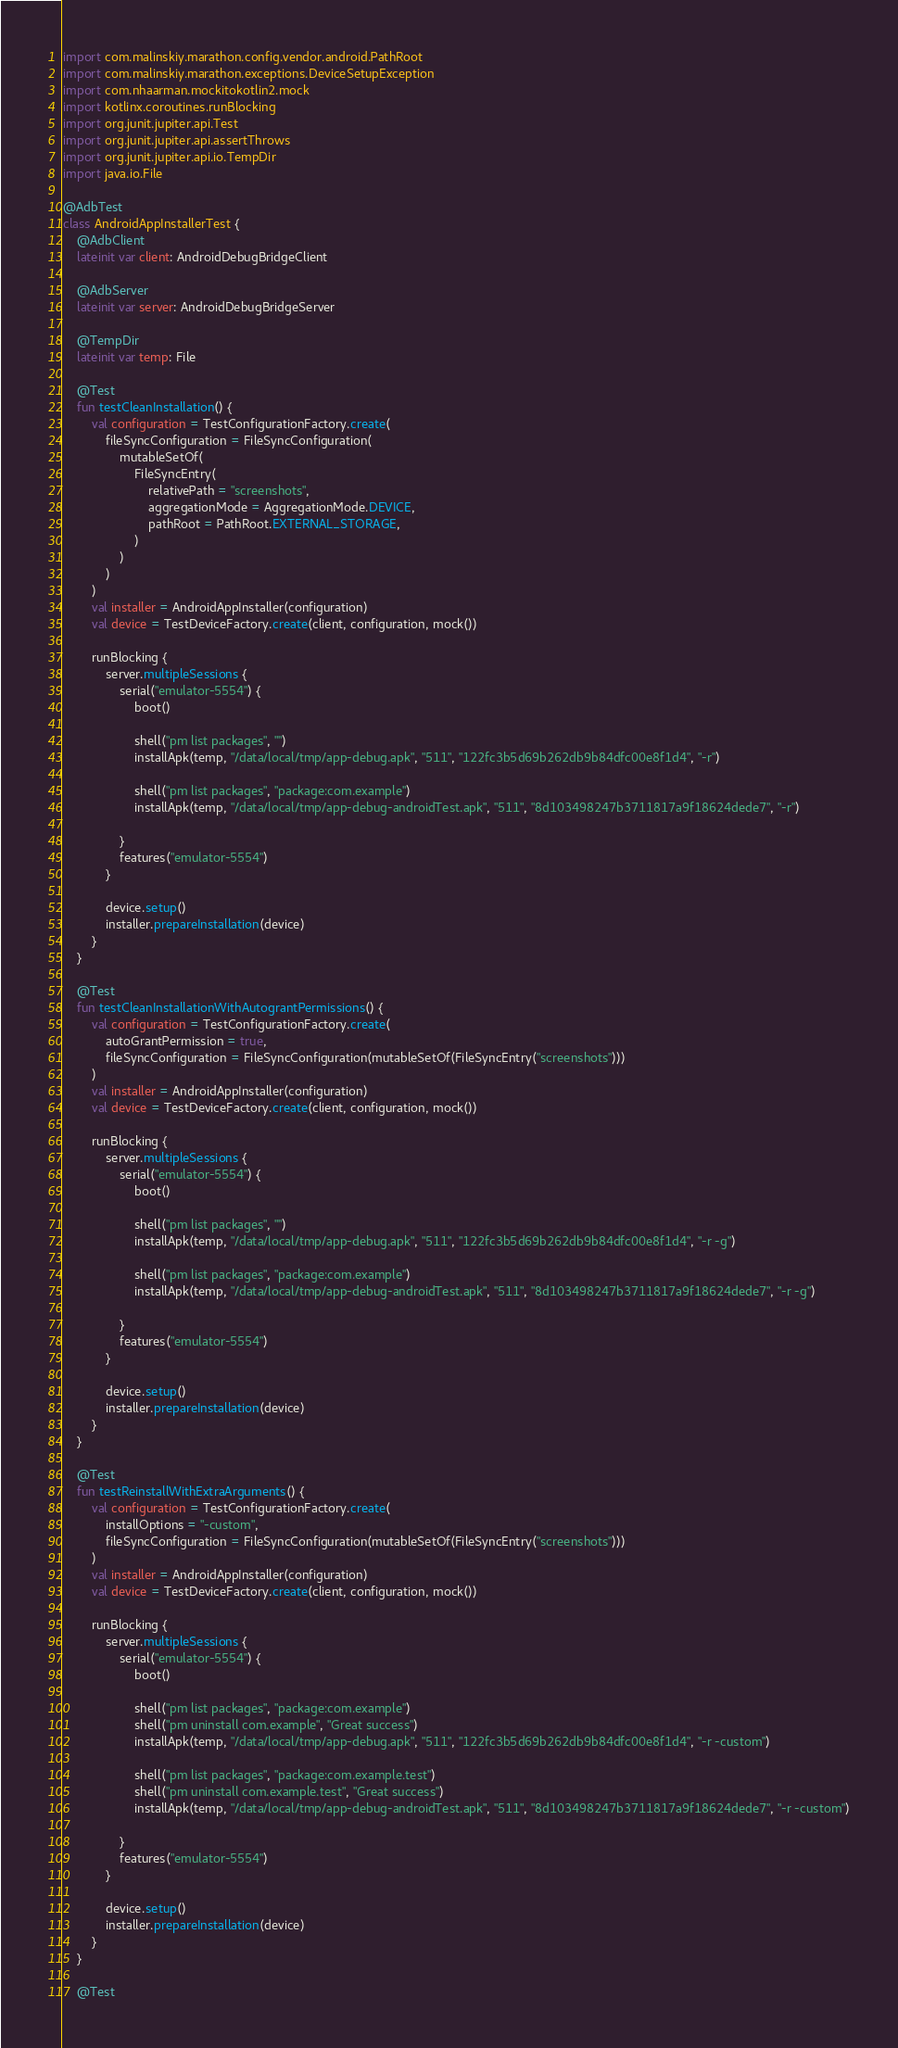<code> <loc_0><loc_0><loc_500><loc_500><_Kotlin_>import com.malinskiy.marathon.config.vendor.android.PathRoot
import com.malinskiy.marathon.exceptions.DeviceSetupException
import com.nhaarman.mockitokotlin2.mock
import kotlinx.coroutines.runBlocking
import org.junit.jupiter.api.Test
import org.junit.jupiter.api.assertThrows
import org.junit.jupiter.api.io.TempDir
import java.io.File

@AdbTest
class AndroidAppInstallerTest {
    @AdbClient
    lateinit var client: AndroidDebugBridgeClient

    @AdbServer
    lateinit var server: AndroidDebugBridgeServer

    @TempDir
    lateinit var temp: File

    @Test
    fun testCleanInstallation() {
        val configuration = TestConfigurationFactory.create(
            fileSyncConfiguration = FileSyncConfiguration(
                mutableSetOf(
                    FileSyncEntry(
                        relativePath = "screenshots",
                        aggregationMode = AggregationMode.DEVICE,
                        pathRoot = PathRoot.EXTERNAL_STORAGE,
                    )
                )
            )
        )
        val installer = AndroidAppInstaller(configuration)
        val device = TestDeviceFactory.create(client, configuration, mock())

        runBlocking {
            server.multipleSessions {
                serial("emulator-5554") {
                    boot()

                    shell("pm list packages", "")
                    installApk(temp, "/data/local/tmp/app-debug.apk", "511", "122fc3b5d69b262db9b84dfc00e8f1d4", "-r")

                    shell("pm list packages", "package:com.example")
                    installApk(temp, "/data/local/tmp/app-debug-androidTest.apk", "511", "8d103498247b3711817a9f18624dede7", "-r")

                }
                features("emulator-5554")
            }

            device.setup()
            installer.prepareInstallation(device)
        }
    }

    @Test
    fun testCleanInstallationWithAutograntPermissions() {
        val configuration = TestConfigurationFactory.create(
            autoGrantPermission = true,
            fileSyncConfiguration = FileSyncConfiguration(mutableSetOf(FileSyncEntry("screenshots")))
        )
        val installer = AndroidAppInstaller(configuration)
        val device = TestDeviceFactory.create(client, configuration, mock())

        runBlocking {
            server.multipleSessions {
                serial("emulator-5554") {
                    boot()

                    shell("pm list packages", "")
                    installApk(temp, "/data/local/tmp/app-debug.apk", "511", "122fc3b5d69b262db9b84dfc00e8f1d4", "-r -g")

                    shell("pm list packages", "package:com.example")
                    installApk(temp, "/data/local/tmp/app-debug-androidTest.apk", "511", "8d103498247b3711817a9f18624dede7", "-r -g")

                }
                features("emulator-5554")
            }

            device.setup()
            installer.prepareInstallation(device)
        }
    }

    @Test
    fun testReinstallWithExtraArguments() {
        val configuration = TestConfigurationFactory.create(
            installOptions = "-custom",
            fileSyncConfiguration = FileSyncConfiguration(mutableSetOf(FileSyncEntry("screenshots")))
        )
        val installer = AndroidAppInstaller(configuration)
        val device = TestDeviceFactory.create(client, configuration, mock())

        runBlocking {
            server.multipleSessions {
                serial("emulator-5554") {
                    boot()

                    shell("pm list packages", "package:com.example")
                    shell("pm uninstall com.example", "Great success")
                    installApk(temp, "/data/local/tmp/app-debug.apk", "511", "122fc3b5d69b262db9b84dfc00e8f1d4", "-r -custom")

                    shell("pm list packages", "package:com.example.test")
                    shell("pm uninstall com.example.test", "Great success")
                    installApk(temp, "/data/local/tmp/app-debug-androidTest.apk", "511", "8d103498247b3711817a9f18624dede7", "-r -custom")

                }
                features("emulator-5554")
            }

            device.setup()
            installer.prepareInstallation(device)
        }
    }

    @Test</code> 